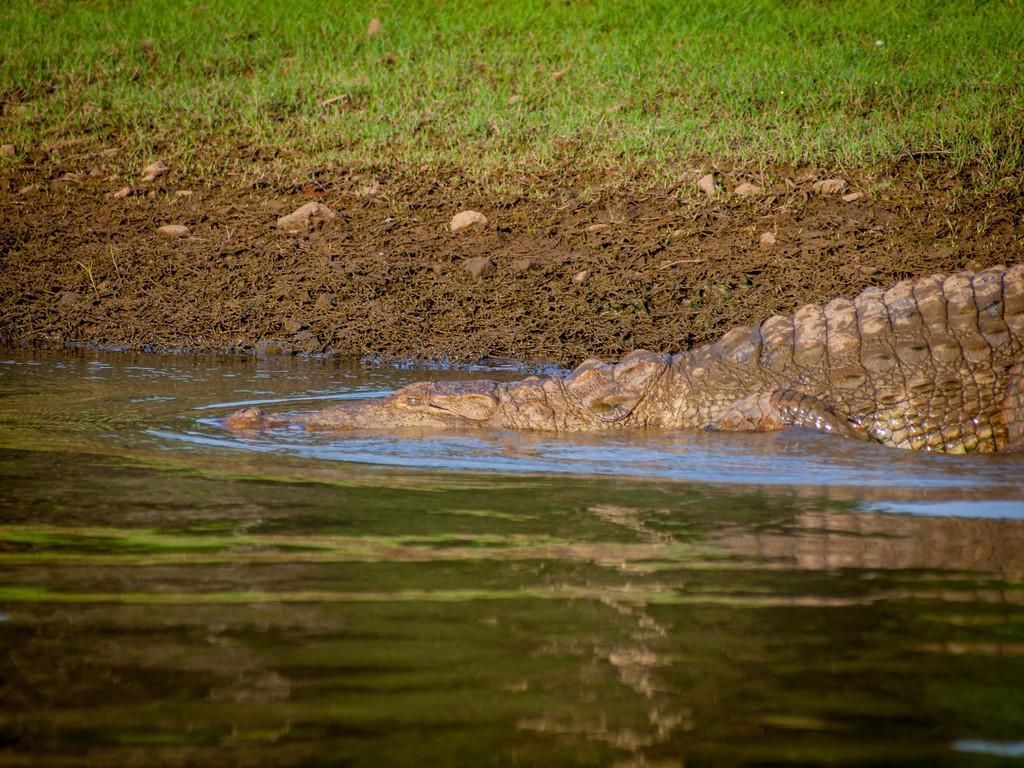Can you describe this image briefly? In this image I see a crocodile over here and I see the water. In the background I see the mud and I see the grass. 